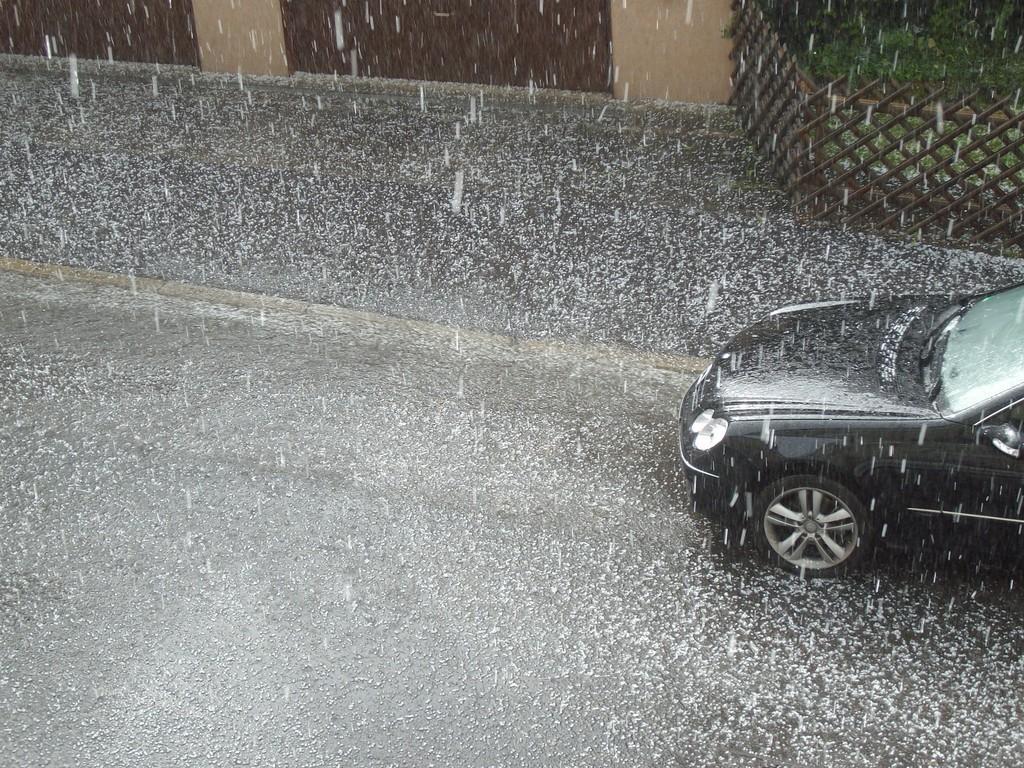Describe this image in one or two sentences. In this image it's raining and there is a car moving on the road. In the background there is a building, at the top right side of the image there is grass and in front of that there is a railing. 